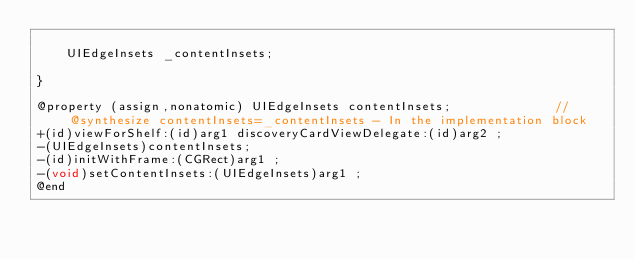Convert code to text. <code><loc_0><loc_0><loc_500><loc_500><_C_>
	UIEdgeInsets _contentInsets;

}

@property (assign,nonatomic) UIEdgeInsets contentInsets;              //@synthesize contentInsets=_contentInsets - In the implementation block
+(id)viewForShelf:(id)arg1 discoveryCardViewDelegate:(id)arg2 ;
-(UIEdgeInsets)contentInsets;
-(id)initWithFrame:(CGRect)arg1 ;
-(void)setContentInsets:(UIEdgeInsets)arg1 ;
@end

</code> 